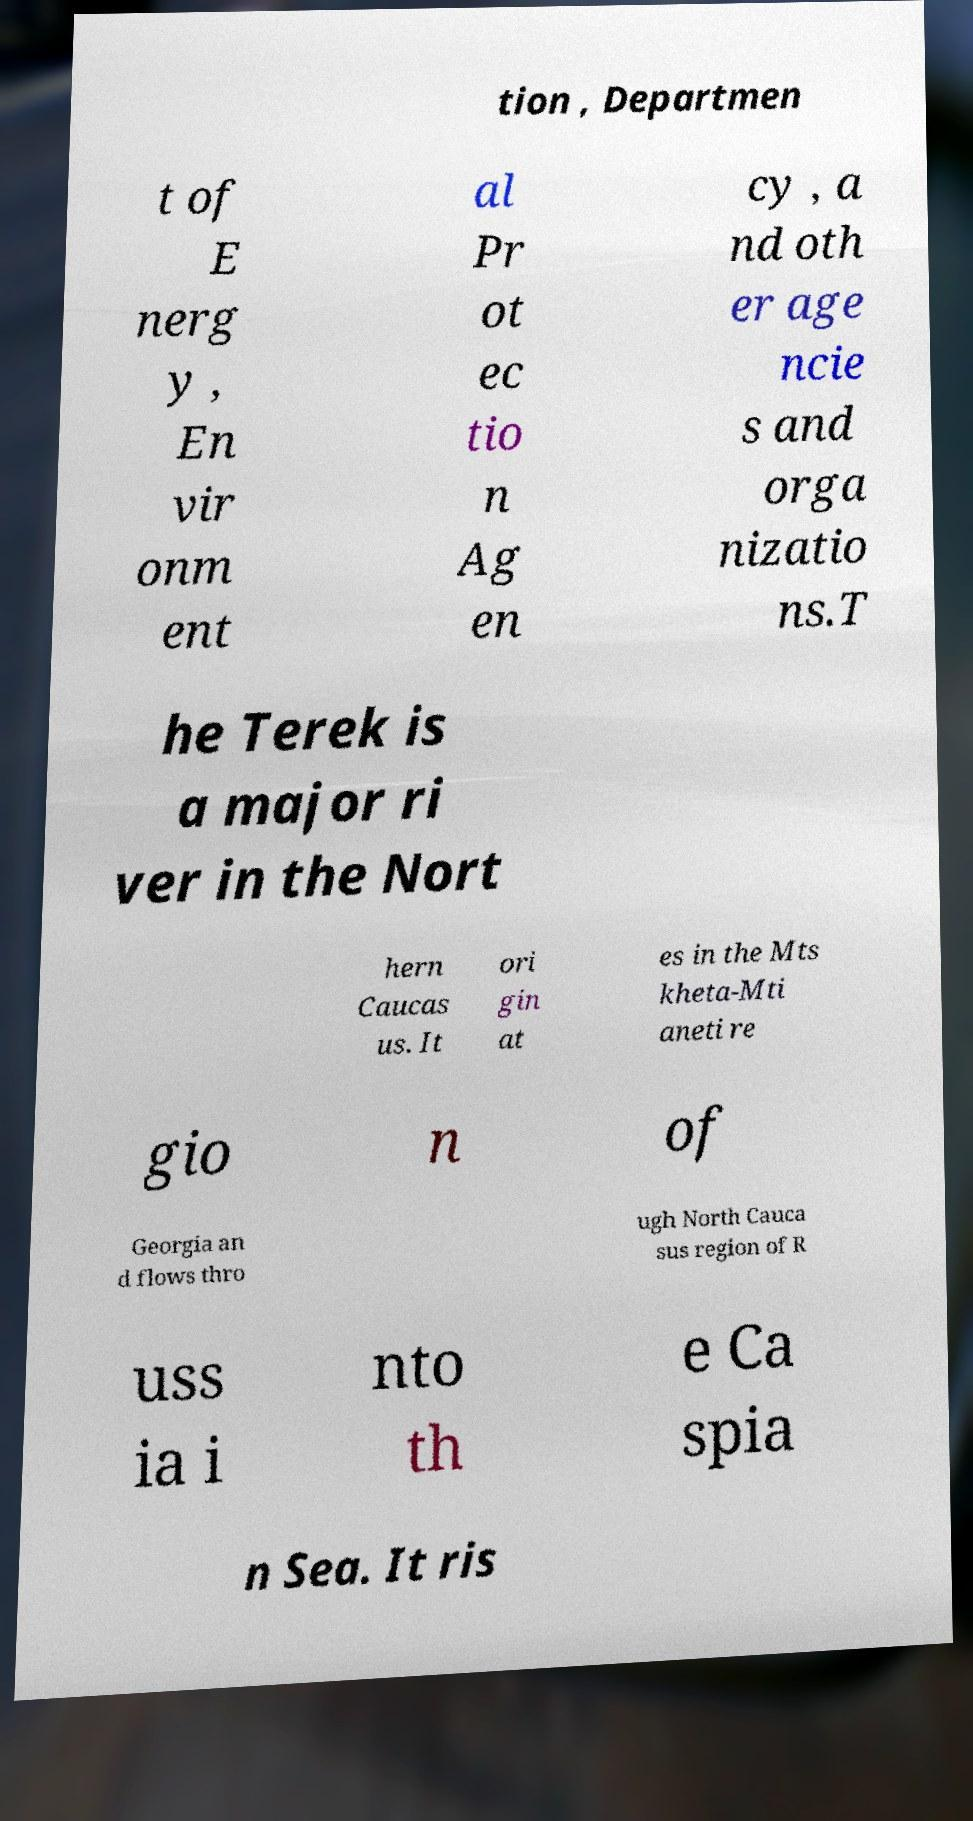Can you accurately transcribe the text from the provided image for me? tion , Departmen t of E nerg y , En vir onm ent al Pr ot ec tio n Ag en cy , a nd oth er age ncie s and orga nizatio ns.T he Terek is a major ri ver in the Nort hern Caucas us. It ori gin at es in the Mts kheta-Mti aneti re gio n of Georgia an d flows thro ugh North Cauca sus region of R uss ia i nto th e Ca spia n Sea. It ris 